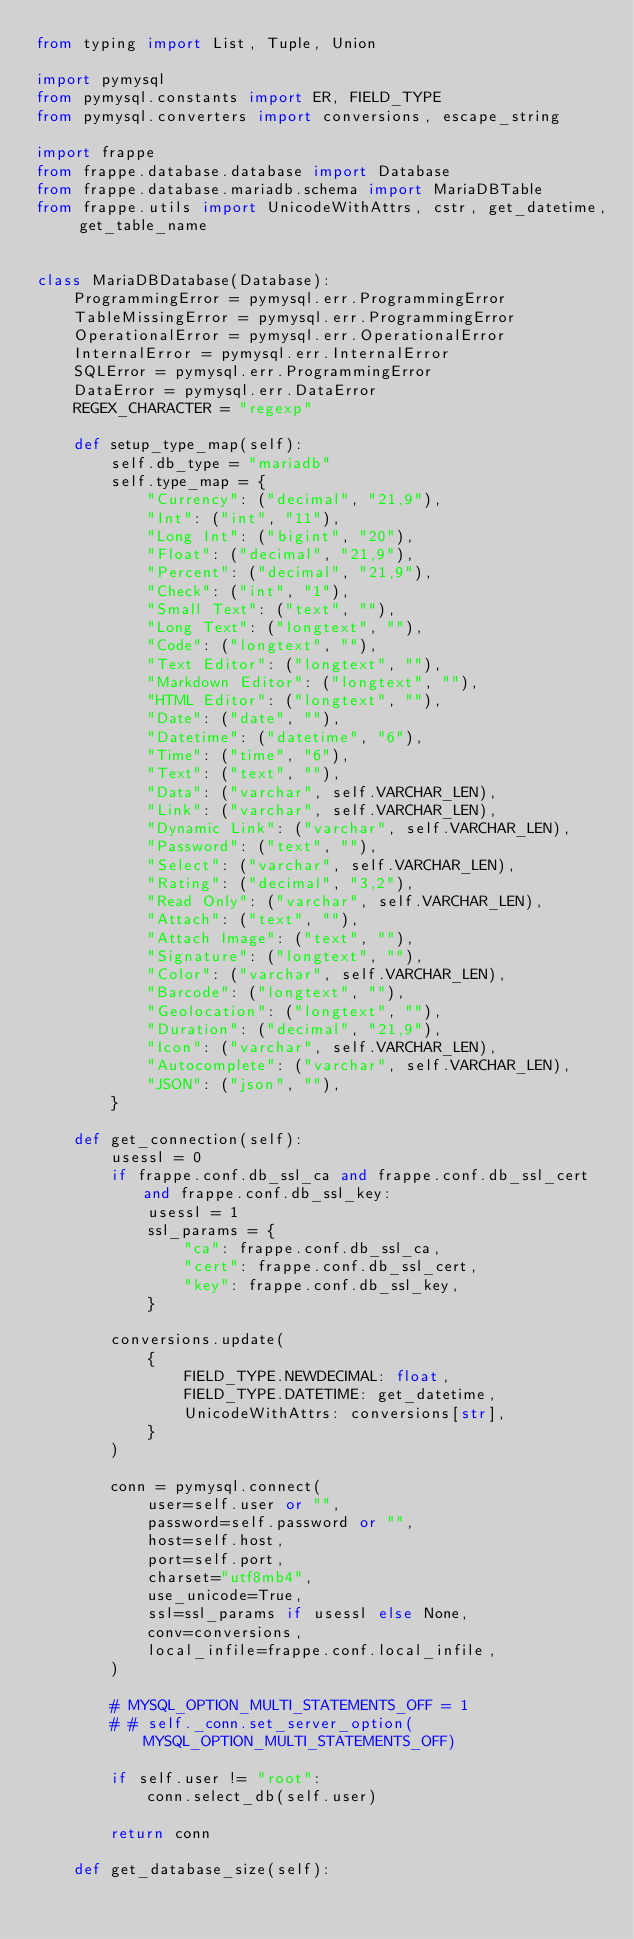<code> <loc_0><loc_0><loc_500><loc_500><_Python_>from typing import List, Tuple, Union

import pymysql
from pymysql.constants import ER, FIELD_TYPE
from pymysql.converters import conversions, escape_string

import frappe
from frappe.database.database import Database
from frappe.database.mariadb.schema import MariaDBTable
from frappe.utils import UnicodeWithAttrs, cstr, get_datetime, get_table_name


class MariaDBDatabase(Database):
	ProgrammingError = pymysql.err.ProgrammingError
	TableMissingError = pymysql.err.ProgrammingError
	OperationalError = pymysql.err.OperationalError
	InternalError = pymysql.err.InternalError
	SQLError = pymysql.err.ProgrammingError
	DataError = pymysql.err.DataError
	REGEX_CHARACTER = "regexp"

	def setup_type_map(self):
		self.db_type = "mariadb"
		self.type_map = {
			"Currency": ("decimal", "21,9"),
			"Int": ("int", "11"),
			"Long Int": ("bigint", "20"),
			"Float": ("decimal", "21,9"),
			"Percent": ("decimal", "21,9"),
			"Check": ("int", "1"),
			"Small Text": ("text", ""),
			"Long Text": ("longtext", ""),
			"Code": ("longtext", ""),
			"Text Editor": ("longtext", ""),
			"Markdown Editor": ("longtext", ""),
			"HTML Editor": ("longtext", ""),
			"Date": ("date", ""),
			"Datetime": ("datetime", "6"),
			"Time": ("time", "6"),
			"Text": ("text", ""),
			"Data": ("varchar", self.VARCHAR_LEN),
			"Link": ("varchar", self.VARCHAR_LEN),
			"Dynamic Link": ("varchar", self.VARCHAR_LEN),
			"Password": ("text", ""),
			"Select": ("varchar", self.VARCHAR_LEN),
			"Rating": ("decimal", "3,2"),
			"Read Only": ("varchar", self.VARCHAR_LEN),
			"Attach": ("text", ""),
			"Attach Image": ("text", ""),
			"Signature": ("longtext", ""),
			"Color": ("varchar", self.VARCHAR_LEN),
			"Barcode": ("longtext", ""),
			"Geolocation": ("longtext", ""),
			"Duration": ("decimal", "21,9"),
			"Icon": ("varchar", self.VARCHAR_LEN),
			"Autocomplete": ("varchar", self.VARCHAR_LEN),
			"JSON": ("json", ""),
		}

	def get_connection(self):
		usessl = 0
		if frappe.conf.db_ssl_ca and frappe.conf.db_ssl_cert and frappe.conf.db_ssl_key:
			usessl = 1
			ssl_params = {
				"ca": frappe.conf.db_ssl_ca,
				"cert": frappe.conf.db_ssl_cert,
				"key": frappe.conf.db_ssl_key,
			}

		conversions.update(
			{
				FIELD_TYPE.NEWDECIMAL: float,
				FIELD_TYPE.DATETIME: get_datetime,
				UnicodeWithAttrs: conversions[str],
			}
		)

		conn = pymysql.connect(
			user=self.user or "",
			password=self.password or "",
			host=self.host,
			port=self.port,
			charset="utf8mb4",
			use_unicode=True,
			ssl=ssl_params if usessl else None,
			conv=conversions,
			local_infile=frappe.conf.local_infile,
		)

		# MYSQL_OPTION_MULTI_STATEMENTS_OFF = 1
		# # self._conn.set_server_option(MYSQL_OPTION_MULTI_STATEMENTS_OFF)

		if self.user != "root":
			conn.select_db(self.user)

		return conn

	def get_database_size(self):</code> 